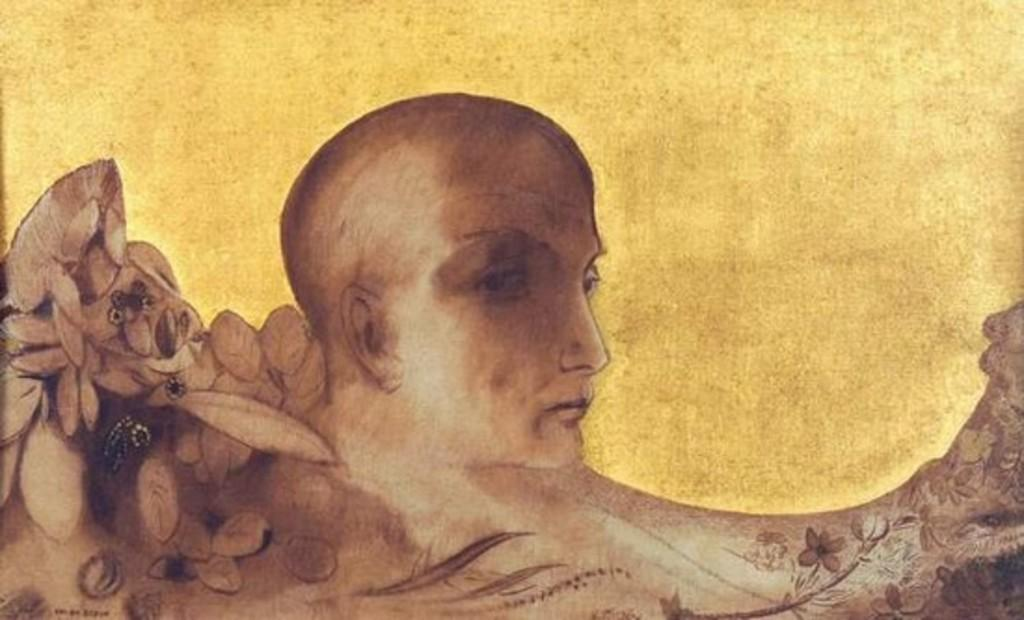What is depicted in the image? The image contains a painting of a man. Can you describe the background of the painting? The background of the painting is yellow in color. What type of cup is being used to hide the man's shame in the image? There is no cup or reference to shame in the image; it features a painting of a man with a yellow background. 